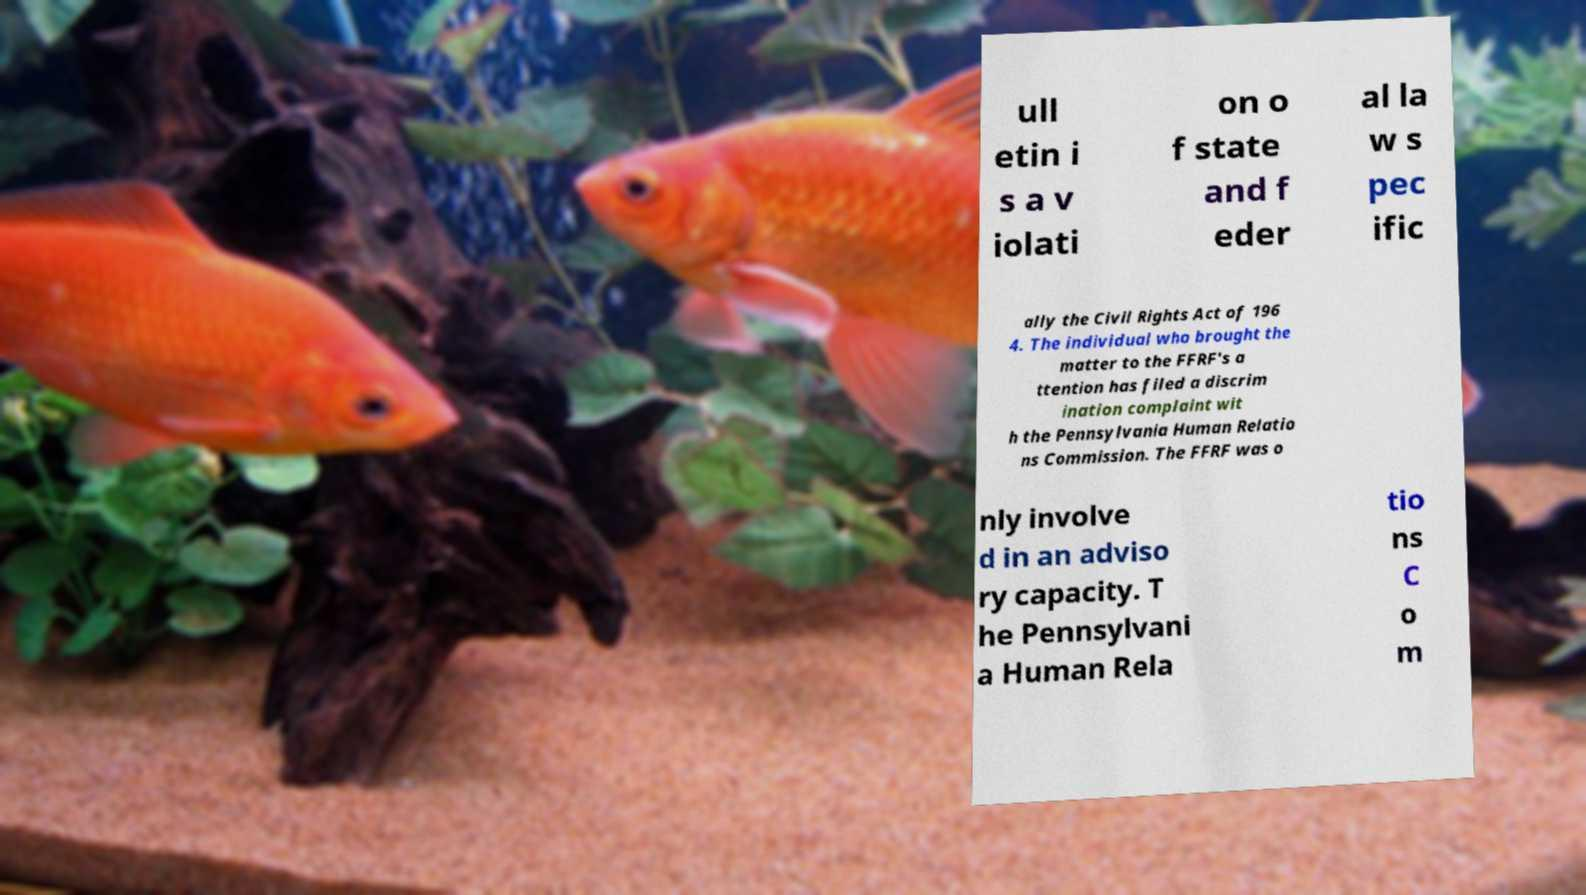I need the written content from this picture converted into text. Can you do that? ull etin i s a v iolati on o f state and f eder al la w s pec ific ally the Civil Rights Act of 196 4. The individual who brought the matter to the FFRF's a ttention has filed a discrim ination complaint wit h the Pennsylvania Human Relatio ns Commission. The FFRF was o nly involve d in an adviso ry capacity. T he Pennsylvani a Human Rela tio ns C o m 